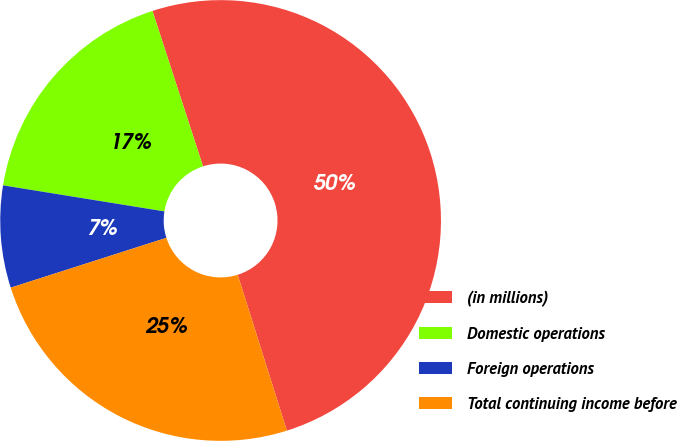Convert chart to OTSL. <chart><loc_0><loc_0><loc_500><loc_500><pie_chart><fcel>(in millions)<fcel>Domestic operations<fcel>Foreign operations<fcel>Total continuing income before<nl><fcel>50.14%<fcel>17.45%<fcel>7.48%<fcel>24.93%<nl></chart> 